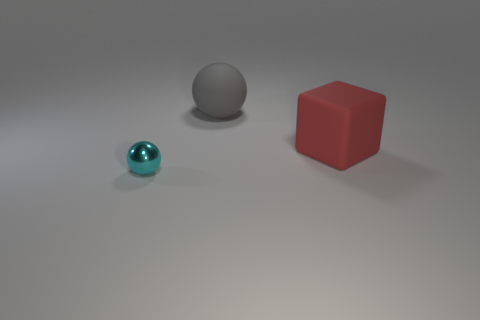Is the number of red matte things that are behind the cyan metallic sphere the same as the number of big red cubes in front of the big gray matte sphere?
Give a very brief answer. Yes. There is a ball behind the tiny sphere; what size is it?
Your response must be concise. Large. Is there a cyan object that has the same material as the cyan ball?
Make the answer very short. No. There is a big rubber object on the left side of the red rubber cube; does it have the same color as the metallic object?
Your answer should be very brief. No. Are there the same number of small cyan metallic objects behind the large red block and large red metal spheres?
Offer a terse response. Yes. Is the block the same size as the gray ball?
Keep it short and to the point. Yes. There is a thing in front of the large matte thing that is in front of the big gray matte ball; what size is it?
Keep it short and to the point. Small. There is a object that is both in front of the rubber ball and behind the metal ball; what is its size?
Make the answer very short. Large. How many red matte objects have the same size as the red block?
Provide a short and direct response. 0. How many rubber things are small green objects or big gray objects?
Provide a short and direct response. 1. 